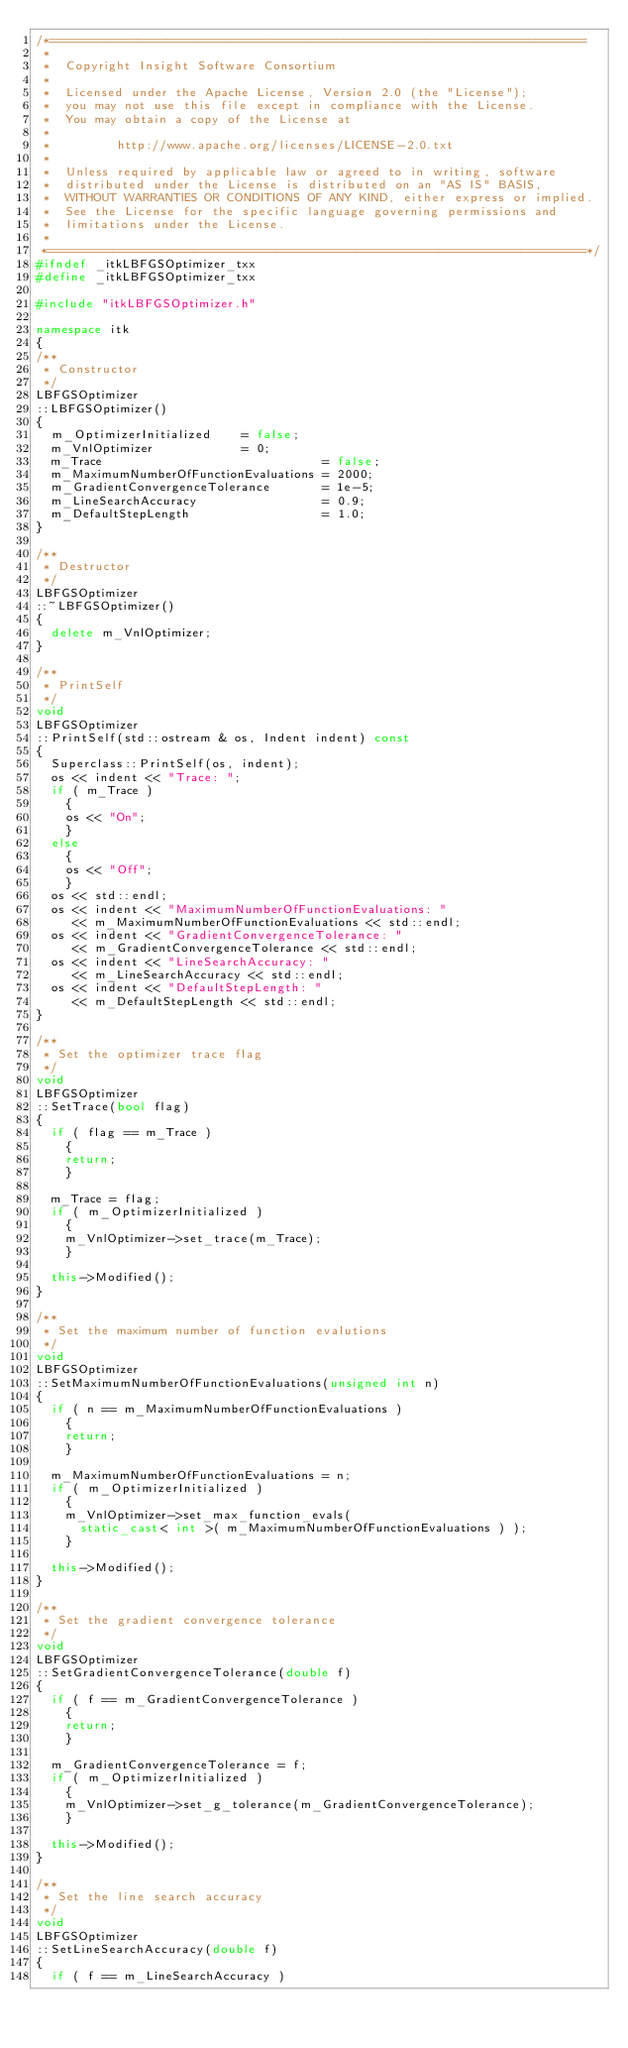Convert code to text. <code><loc_0><loc_0><loc_500><loc_500><_C++_>/*=========================================================================
 *
 *  Copyright Insight Software Consortium
 *
 *  Licensed under the Apache License, Version 2.0 (the "License");
 *  you may not use this file except in compliance with the License.
 *  You may obtain a copy of the License at
 *
 *         http://www.apache.org/licenses/LICENSE-2.0.txt
 *
 *  Unless required by applicable law or agreed to in writing, software
 *  distributed under the License is distributed on an "AS IS" BASIS,
 *  WITHOUT WARRANTIES OR CONDITIONS OF ANY KIND, either express or implied.
 *  See the License for the specific language governing permissions and
 *  limitations under the License.
 *
 *=========================================================================*/
#ifndef _itkLBFGSOptimizer_txx
#define _itkLBFGSOptimizer_txx

#include "itkLBFGSOptimizer.h"

namespace itk
{
/**
 * Constructor
 */
LBFGSOptimizer
::LBFGSOptimizer()
{
  m_OptimizerInitialized    = false;
  m_VnlOptimizer            = 0;
  m_Trace                              = false;
  m_MaximumNumberOfFunctionEvaluations = 2000;
  m_GradientConvergenceTolerance       = 1e-5;
  m_LineSearchAccuracy                 = 0.9;
  m_DefaultStepLength                  = 1.0;
}

/**
 * Destructor
 */
LBFGSOptimizer
::~LBFGSOptimizer()
{
  delete m_VnlOptimizer;
}

/**
 * PrintSelf
 */
void
LBFGSOptimizer
::PrintSelf(std::ostream & os, Indent indent) const
{
  Superclass::PrintSelf(os, indent);
  os << indent << "Trace: ";
  if ( m_Trace )
    {
    os << "On";
    }
  else
    {
    os << "Off";
    }
  os << std::endl;
  os << indent << "MaximumNumberOfFunctionEvaluations: "
     << m_MaximumNumberOfFunctionEvaluations << std::endl;
  os << indent << "GradientConvergenceTolerance: "
     << m_GradientConvergenceTolerance << std::endl;
  os << indent << "LineSearchAccuracy: "
     << m_LineSearchAccuracy << std::endl;
  os << indent << "DefaultStepLength: "
     << m_DefaultStepLength << std::endl;
}

/**
 * Set the optimizer trace flag
 */
void
LBFGSOptimizer
::SetTrace(bool flag)
{
  if ( flag == m_Trace )
    {
    return;
    }

  m_Trace = flag;
  if ( m_OptimizerInitialized )
    {
    m_VnlOptimizer->set_trace(m_Trace);
    }

  this->Modified();
}

/**
 * Set the maximum number of function evalutions
 */
void
LBFGSOptimizer
::SetMaximumNumberOfFunctionEvaluations(unsigned int n)
{
  if ( n == m_MaximumNumberOfFunctionEvaluations )
    {
    return;
    }

  m_MaximumNumberOfFunctionEvaluations = n;
  if ( m_OptimizerInitialized )
    {
    m_VnlOptimizer->set_max_function_evals(
      static_cast< int >( m_MaximumNumberOfFunctionEvaluations ) );
    }

  this->Modified();
}

/**
 * Set the gradient convergence tolerance
 */
void
LBFGSOptimizer
::SetGradientConvergenceTolerance(double f)
{
  if ( f == m_GradientConvergenceTolerance )
    {
    return;
    }

  m_GradientConvergenceTolerance = f;
  if ( m_OptimizerInitialized )
    {
    m_VnlOptimizer->set_g_tolerance(m_GradientConvergenceTolerance);
    }

  this->Modified();
}

/**
 * Set the line search accuracy
 */
void
LBFGSOptimizer
::SetLineSearchAccuracy(double f)
{
  if ( f == m_LineSearchAccuracy )</code> 